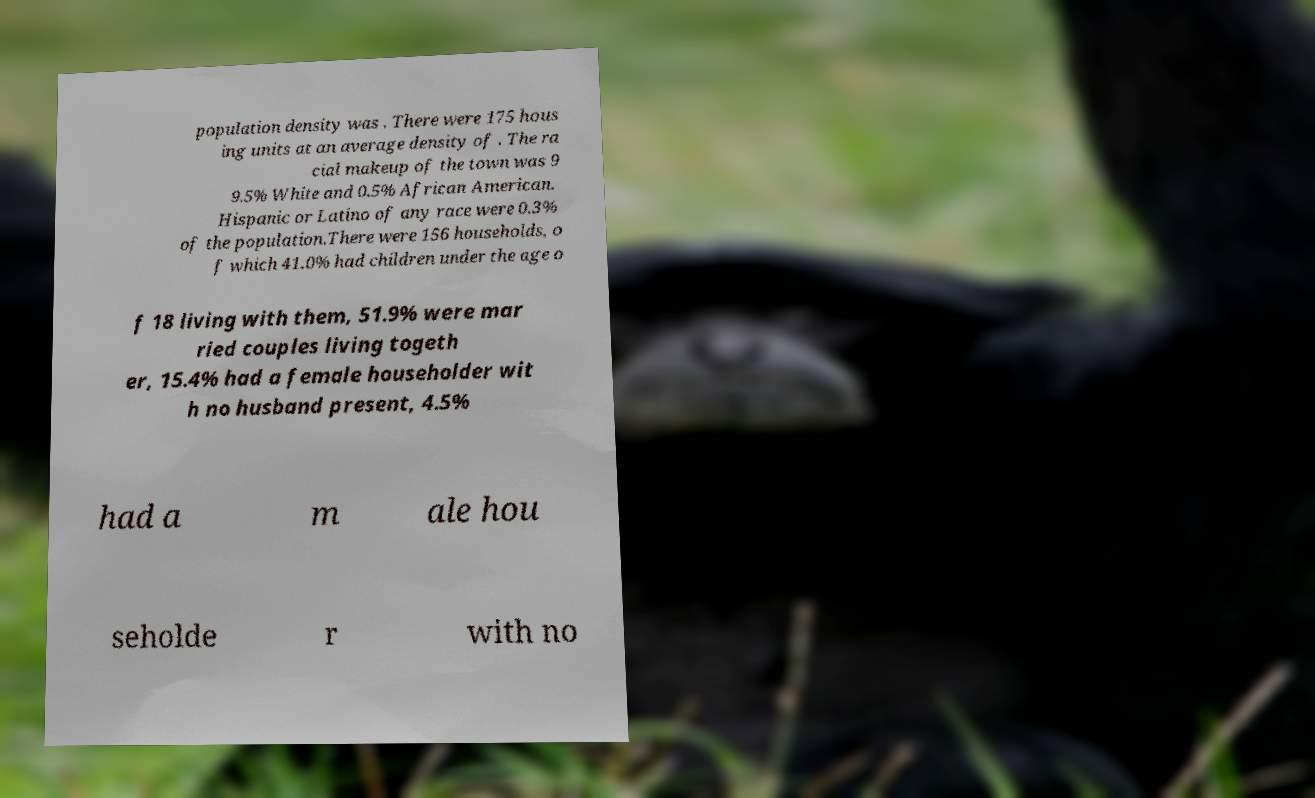Please identify and transcribe the text found in this image. population density was . There were 175 hous ing units at an average density of . The ra cial makeup of the town was 9 9.5% White and 0.5% African American. Hispanic or Latino of any race were 0.3% of the population.There were 156 households, o f which 41.0% had children under the age o f 18 living with them, 51.9% were mar ried couples living togeth er, 15.4% had a female householder wit h no husband present, 4.5% had a m ale hou seholde r with no 